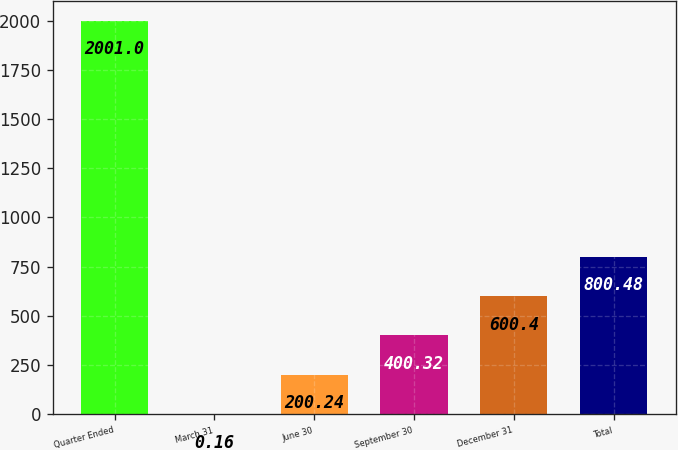<chart> <loc_0><loc_0><loc_500><loc_500><bar_chart><fcel>Quarter Ended<fcel>March 31<fcel>June 30<fcel>September 30<fcel>December 31<fcel>Total<nl><fcel>2001<fcel>0.16<fcel>200.24<fcel>400.32<fcel>600.4<fcel>800.48<nl></chart> 